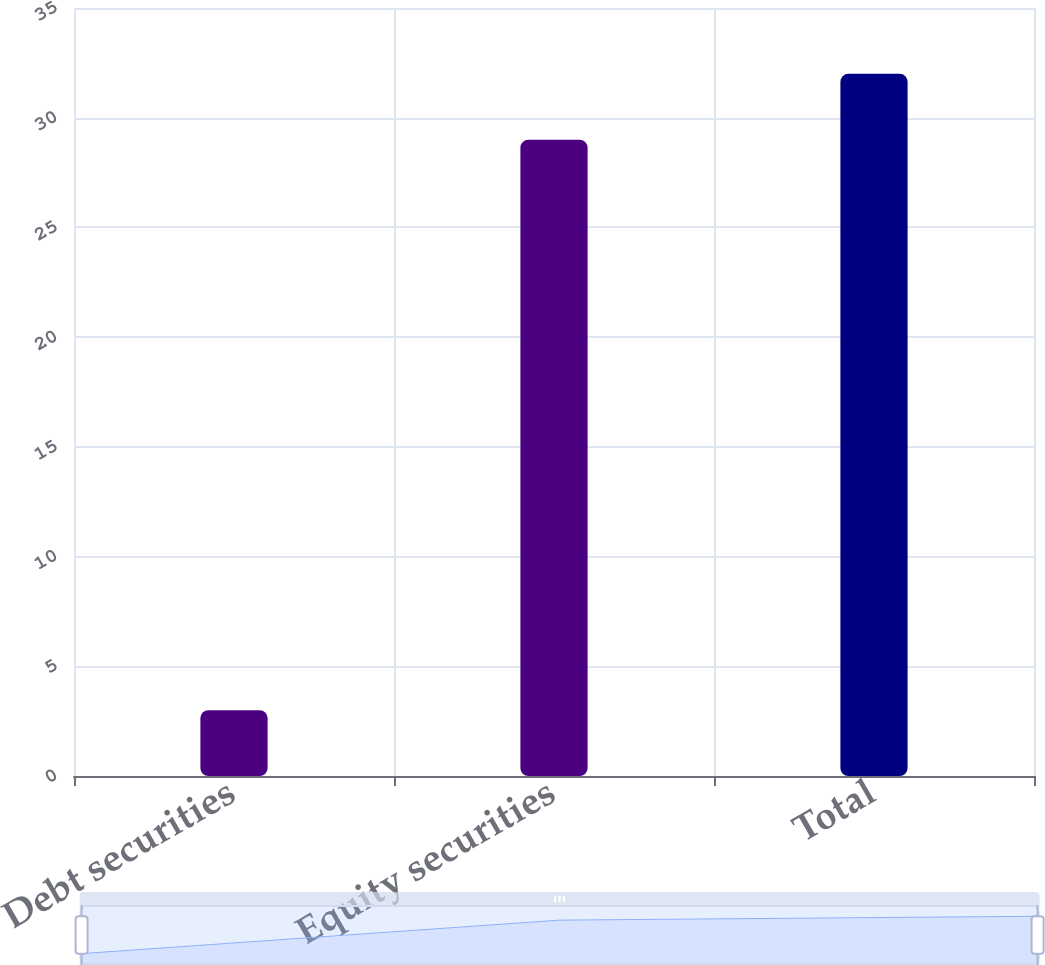<chart> <loc_0><loc_0><loc_500><loc_500><bar_chart><fcel>Debt securities<fcel>Equity securities<fcel>Total<nl><fcel>3<fcel>29<fcel>32<nl></chart> 